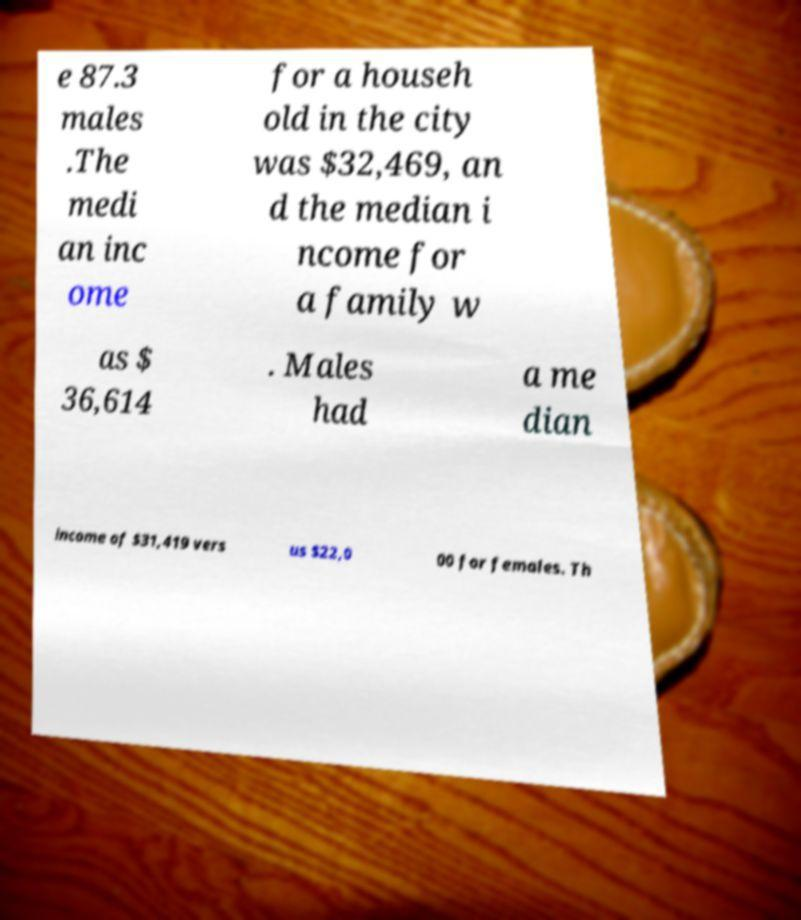I need the written content from this picture converted into text. Can you do that? e 87.3 males .The medi an inc ome for a househ old in the city was $32,469, an d the median i ncome for a family w as $ 36,614 . Males had a me dian income of $31,419 vers us $22,0 00 for females. Th 